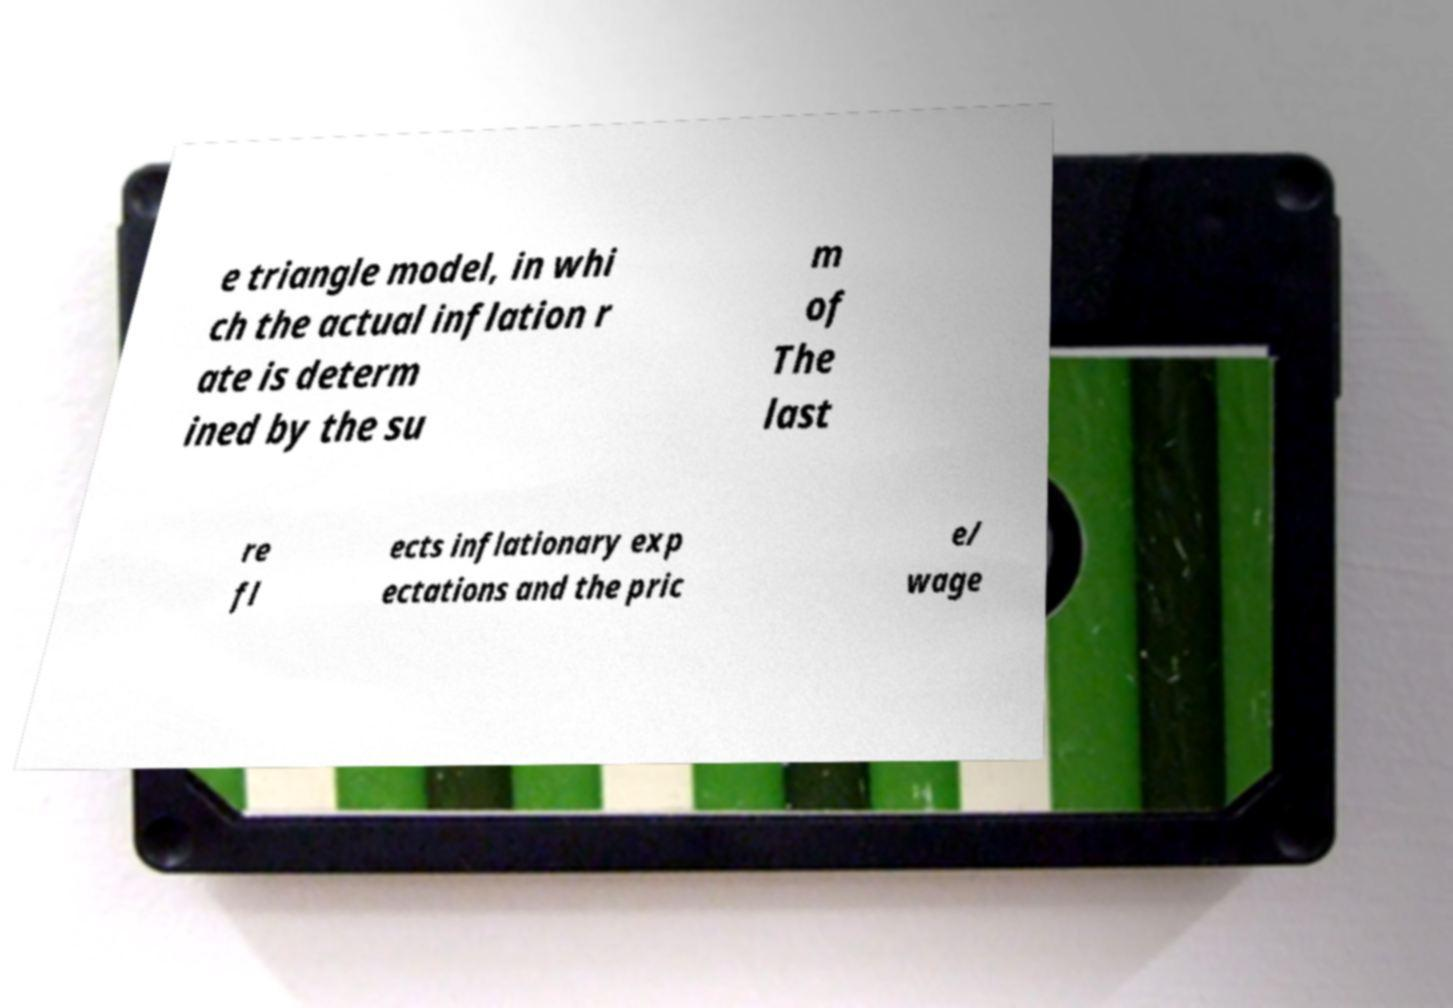What messages or text are displayed in this image? I need them in a readable, typed format. e triangle model, in whi ch the actual inflation r ate is determ ined by the su m of The last re fl ects inflationary exp ectations and the pric e/ wage 